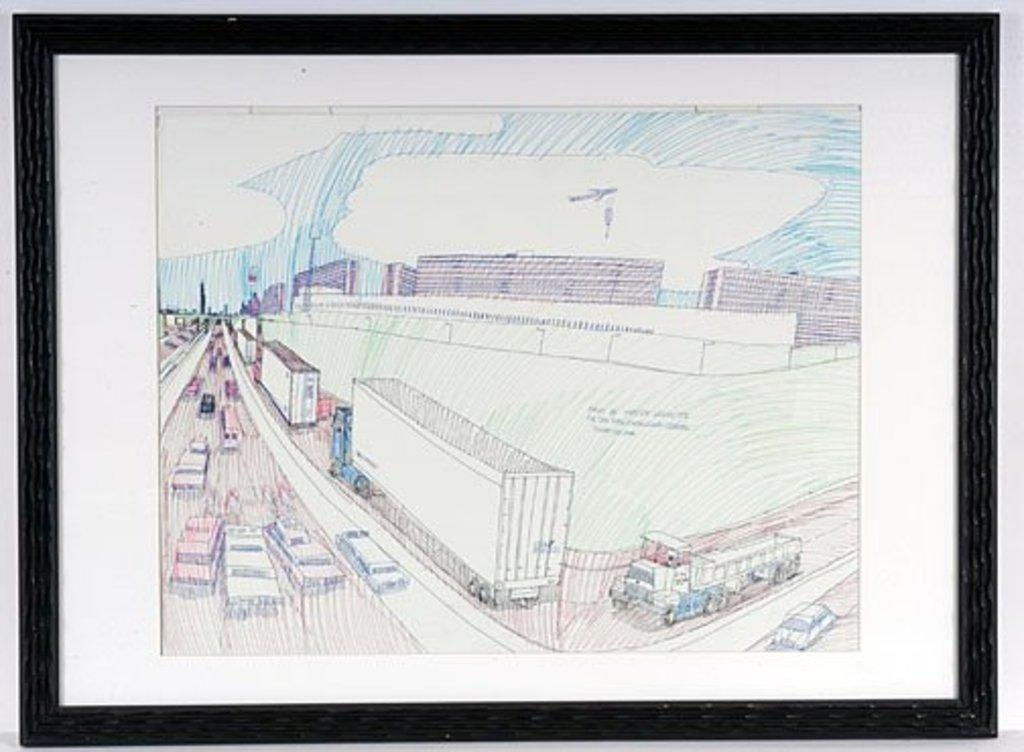What is contained within the frame in the image? There is a white paper in the frame. What is depicted on the white paper? There is art on the white paper. What can be seen in the background of the image? There is a road visible in the image, with vehicles on it, as well as buildings and the sky. What type of floor can be seen in the image? There is no floor visible in the image; it primarily features a frame with a white paper and art, as well as a background with a road, vehicles, buildings, and the sky. 